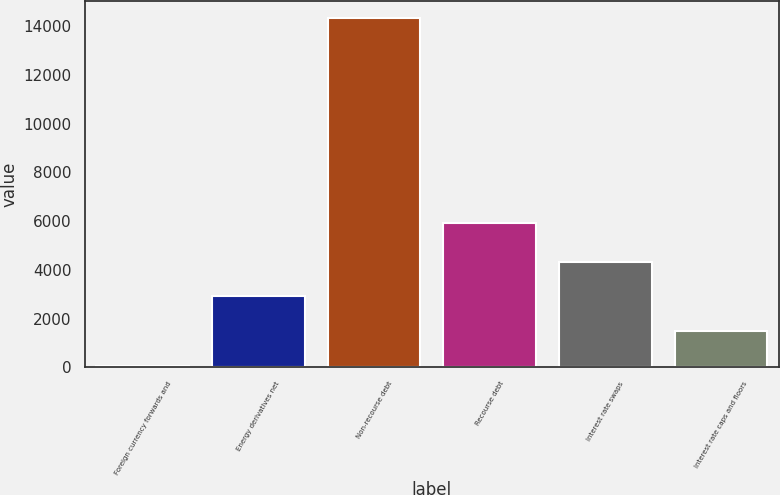Convert chart. <chart><loc_0><loc_0><loc_500><loc_500><bar_chart><fcel>Foreign currency forwards and<fcel>Energy derivatives net<fcel>Non-recourse debt<fcel>Recourse debt<fcel>Interest rate swaps<fcel>Interest rate caps and floors<nl><fcel>56<fcel>2911.8<fcel>14335<fcel>5939<fcel>4339.7<fcel>1483.9<nl></chart> 